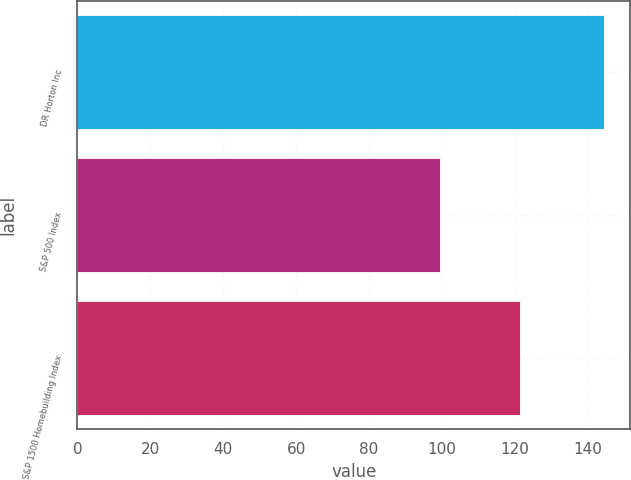<chart> <loc_0><loc_0><loc_500><loc_500><bar_chart><fcel>DR Horton Inc<fcel>S&P 500 Index<fcel>S&P 1500 Homebuilding Index<nl><fcel>144.45<fcel>99.39<fcel>121.48<nl></chart> 